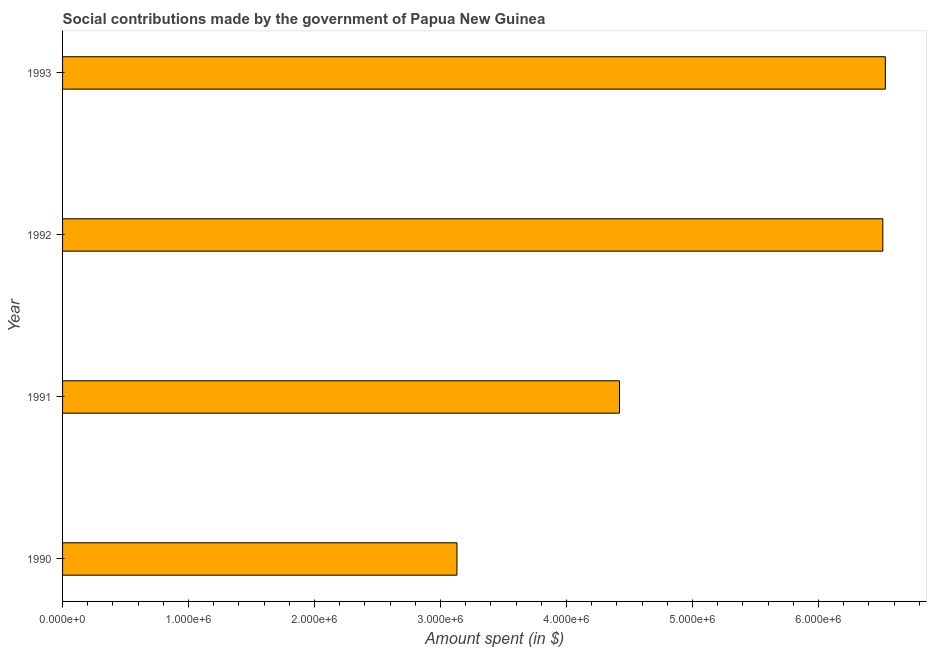Does the graph contain any zero values?
Provide a short and direct response. No. What is the title of the graph?
Provide a succinct answer. Social contributions made by the government of Papua New Guinea. What is the label or title of the X-axis?
Offer a very short reply. Amount spent (in $). What is the amount spent in making social contributions in 1993?
Keep it short and to the point. 6.53e+06. Across all years, what is the maximum amount spent in making social contributions?
Provide a succinct answer. 6.53e+06. Across all years, what is the minimum amount spent in making social contributions?
Your answer should be very brief. 3.13e+06. In which year was the amount spent in making social contributions minimum?
Your answer should be compact. 1990. What is the sum of the amount spent in making social contributions?
Provide a short and direct response. 2.06e+07. What is the difference between the amount spent in making social contributions in 1990 and 1993?
Offer a terse response. -3.40e+06. What is the average amount spent in making social contributions per year?
Provide a short and direct response. 5.15e+06. What is the median amount spent in making social contributions?
Your response must be concise. 5.46e+06. In how many years, is the amount spent in making social contributions greater than 6400000 $?
Provide a succinct answer. 2. What is the ratio of the amount spent in making social contributions in 1992 to that in 1993?
Make the answer very short. 1. What is the difference between the highest and the second highest amount spent in making social contributions?
Your response must be concise. 2.00e+04. What is the difference between the highest and the lowest amount spent in making social contributions?
Your response must be concise. 3.40e+06. How many bars are there?
Offer a very short reply. 4. What is the difference between two consecutive major ticks on the X-axis?
Give a very brief answer. 1.00e+06. What is the Amount spent (in $) in 1990?
Your response must be concise. 3.13e+06. What is the Amount spent (in $) in 1991?
Your answer should be very brief. 4.42e+06. What is the Amount spent (in $) of 1992?
Provide a succinct answer. 6.51e+06. What is the Amount spent (in $) in 1993?
Your response must be concise. 6.53e+06. What is the difference between the Amount spent (in $) in 1990 and 1991?
Ensure brevity in your answer.  -1.29e+06. What is the difference between the Amount spent (in $) in 1990 and 1992?
Your response must be concise. -3.38e+06. What is the difference between the Amount spent (in $) in 1990 and 1993?
Provide a succinct answer. -3.40e+06. What is the difference between the Amount spent (in $) in 1991 and 1992?
Keep it short and to the point. -2.09e+06. What is the difference between the Amount spent (in $) in 1991 and 1993?
Offer a very short reply. -2.11e+06. What is the ratio of the Amount spent (in $) in 1990 to that in 1991?
Your answer should be very brief. 0.71. What is the ratio of the Amount spent (in $) in 1990 to that in 1992?
Ensure brevity in your answer.  0.48. What is the ratio of the Amount spent (in $) in 1990 to that in 1993?
Make the answer very short. 0.48. What is the ratio of the Amount spent (in $) in 1991 to that in 1992?
Keep it short and to the point. 0.68. What is the ratio of the Amount spent (in $) in 1991 to that in 1993?
Offer a terse response. 0.68. What is the ratio of the Amount spent (in $) in 1992 to that in 1993?
Keep it short and to the point. 1. 